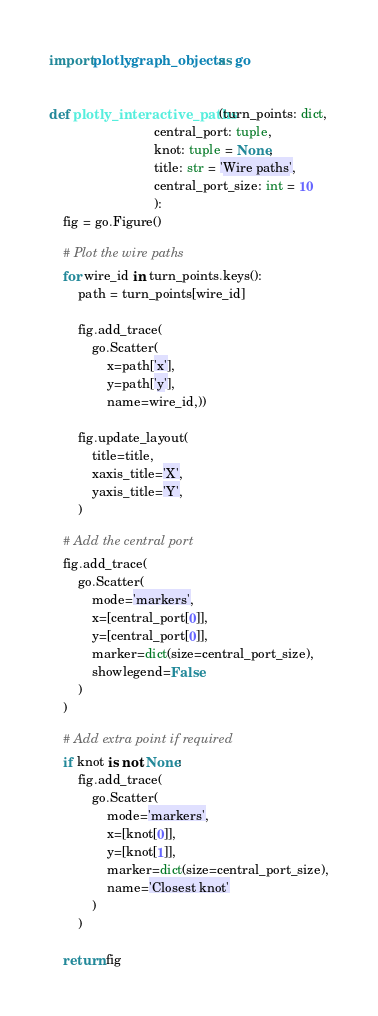Convert code to text. <code><loc_0><loc_0><loc_500><loc_500><_Python_>import plotly.graph_objects as go


def plotly_interactive_paths(turn_points: dict,
                             central_port: tuple,
                             knot: tuple = None,
                             title: str = 'Wire paths',
                             central_port_size: int = 10
                             ):
    fig = go.Figure()

    # Plot the wire paths
    for wire_id in turn_points.keys():
        path = turn_points[wire_id]

        fig.add_trace(
            go.Scatter(
                x=path['x'],
                y=path['y'],
                name=wire_id,))

        fig.update_layout(
            title=title,
            xaxis_title='X',
            yaxis_title='Y',
        )

    # Add the central port
    fig.add_trace(
        go.Scatter(
            mode='markers',
            x=[central_port[0]],
            y=[central_port[0]],
            marker=dict(size=central_port_size),
            showlegend=False
        )
    )

    # Add extra point if required
    if knot is not None:
        fig.add_trace(
            go.Scatter(
                mode='markers',
                x=[knot[0]],
                y=[knot[1]],
                marker=dict(size=central_port_size),
                name='Closest knot'
            )
        )

    return fig
</code> 